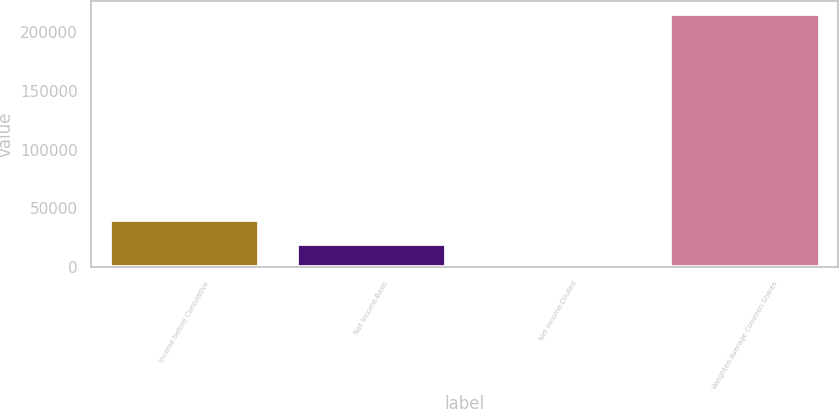<chart> <loc_0><loc_0><loc_500><loc_500><bar_chart><fcel>Income before Cumulative<fcel>Net Income-Basic<fcel>Net Income-Diluted<fcel>Weighted Average Common Shares<nl><fcel>39621.2<fcel>19810.9<fcel>0.56<fcel>215798<nl></chart> 